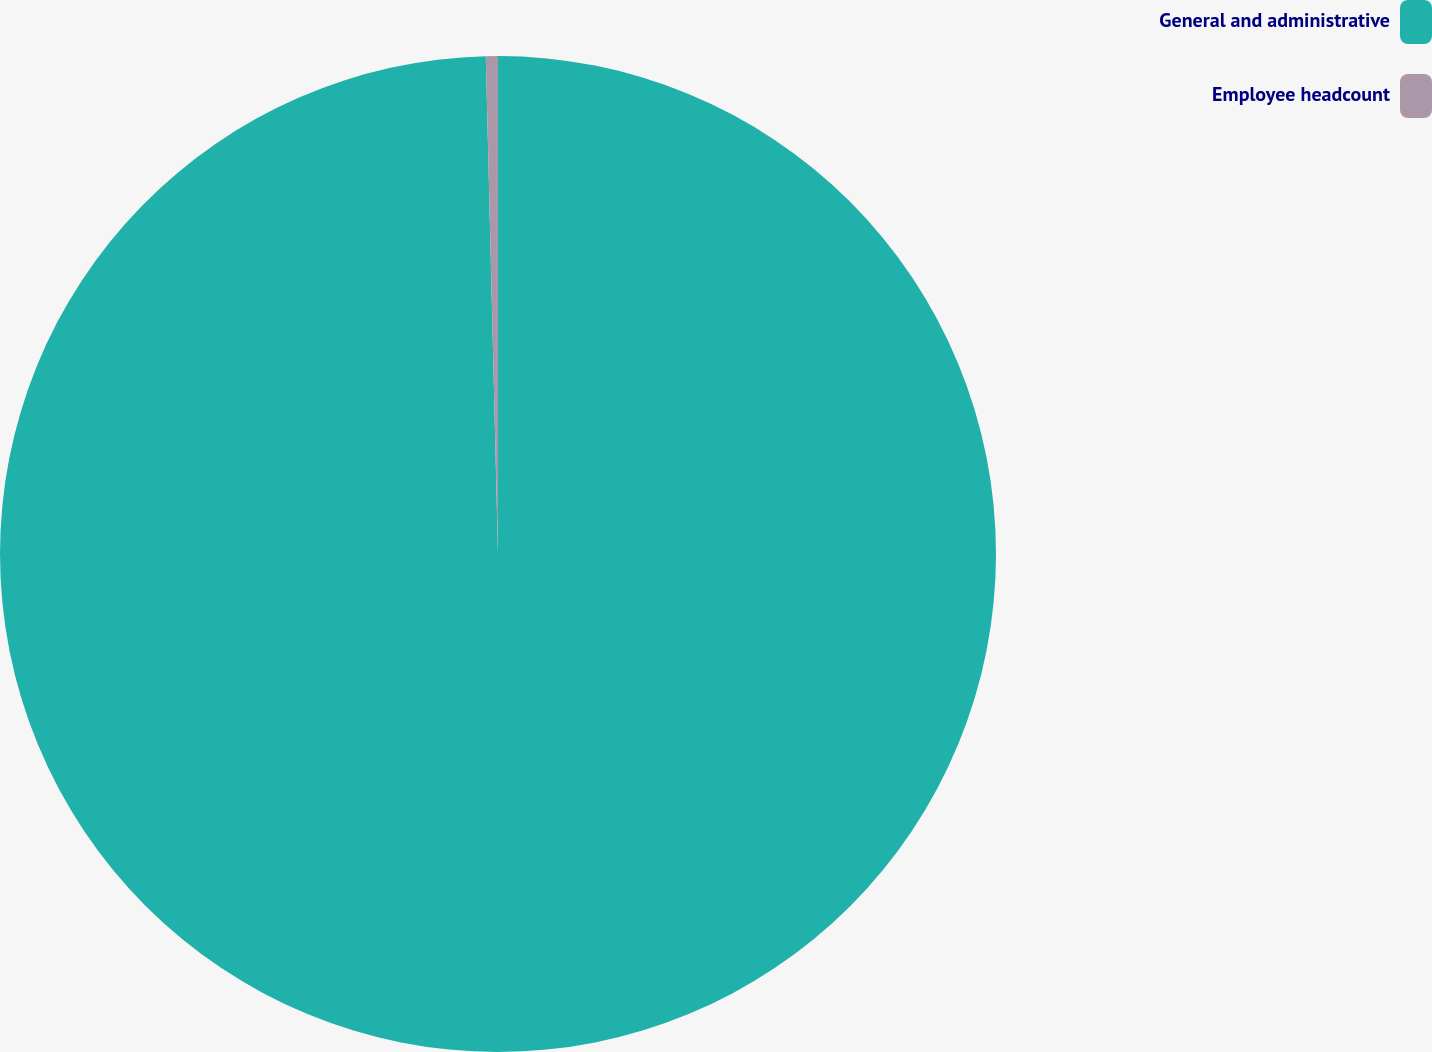Convert chart to OTSL. <chart><loc_0><loc_0><loc_500><loc_500><pie_chart><fcel>General and administrative<fcel>Employee headcount<nl><fcel>99.61%<fcel>0.39%<nl></chart> 